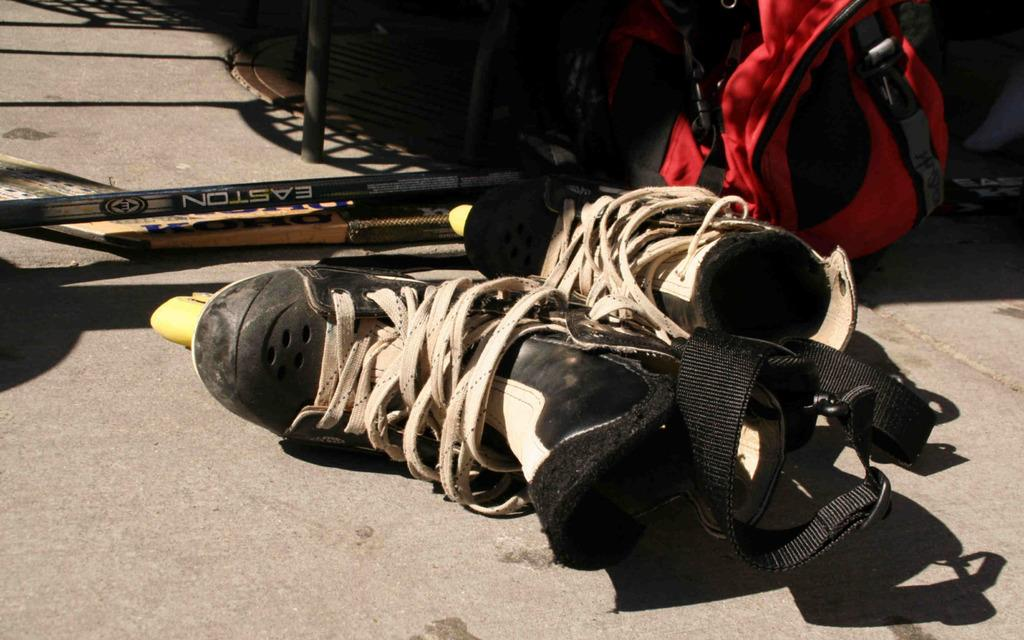What type of footwear is visible in the image? There is a pair of shoes in the image. What else can be seen in the image besides the shoes? There is a bag and other objects on the road in the image. How many frogs are sitting on the shoes in the image? There are no frogs present in the image. Is the bag in the image being used as a makeshift jail for any animals? There is no indication of a jail or any animals in the image. 